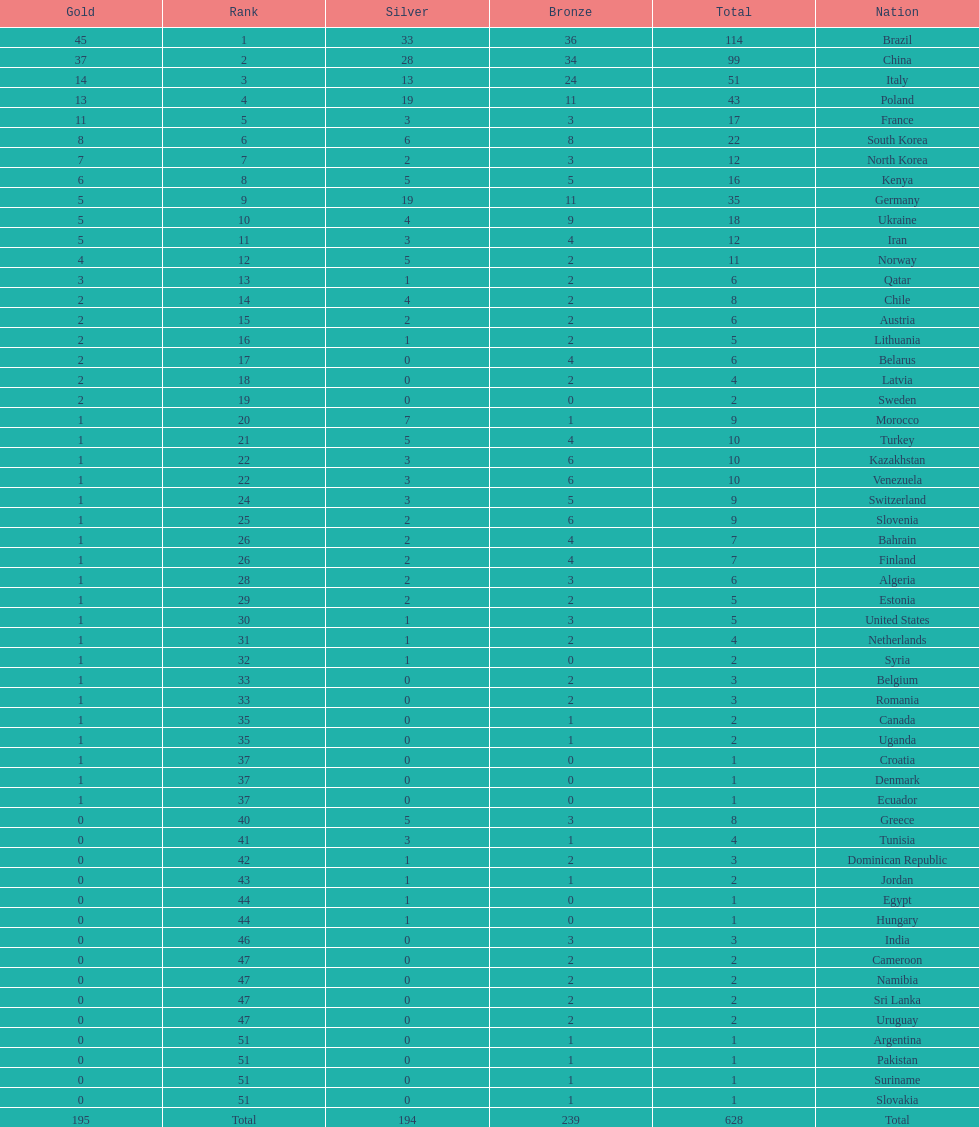Can you give me this table as a dict? {'header': ['Gold', 'Rank', 'Silver', 'Bronze', 'Total', 'Nation'], 'rows': [['45', '1', '33', '36', '114', 'Brazil'], ['37', '2', '28', '34', '99', 'China'], ['14', '3', '13', '24', '51', 'Italy'], ['13', '4', '19', '11', '43', 'Poland'], ['11', '5', '3', '3', '17', 'France'], ['8', '6', '6', '8', '22', 'South Korea'], ['7', '7', '2', '3', '12', 'North Korea'], ['6', '8', '5', '5', '16', 'Kenya'], ['5', '9', '19', '11', '35', 'Germany'], ['5', '10', '4', '9', '18', 'Ukraine'], ['5', '11', '3', '4', '12', 'Iran'], ['4', '12', '5', '2', '11', 'Norway'], ['3', '13', '1', '2', '6', 'Qatar'], ['2', '14', '4', '2', '8', 'Chile'], ['2', '15', '2', '2', '6', 'Austria'], ['2', '16', '1', '2', '5', 'Lithuania'], ['2', '17', '0', '4', '6', 'Belarus'], ['2', '18', '0', '2', '4', 'Latvia'], ['2', '19', '0', '0', '2', 'Sweden'], ['1', '20', '7', '1', '9', 'Morocco'], ['1', '21', '5', '4', '10', 'Turkey'], ['1', '22', '3', '6', '10', 'Kazakhstan'], ['1', '22', '3', '6', '10', 'Venezuela'], ['1', '24', '3', '5', '9', 'Switzerland'], ['1', '25', '2', '6', '9', 'Slovenia'], ['1', '26', '2', '4', '7', 'Bahrain'], ['1', '26', '2', '4', '7', 'Finland'], ['1', '28', '2', '3', '6', 'Algeria'], ['1', '29', '2', '2', '5', 'Estonia'], ['1', '30', '1', '3', '5', 'United States'], ['1', '31', '1', '2', '4', 'Netherlands'], ['1', '32', '1', '0', '2', 'Syria'], ['1', '33', '0', '2', '3', 'Belgium'], ['1', '33', '0', '2', '3', 'Romania'], ['1', '35', '0', '1', '2', 'Canada'], ['1', '35', '0', '1', '2', 'Uganda'], ['1', '37', '0', '0', '1', 'Croatia'], ['1', '37', '0', '0', '1', 'Denmark'], ['1', '37', '0', '0', '1', 'Ecuador'], ['0', '40', '5', '3', '8', 'Greece'], ['0', '41', '3', '1', '4', 'Tunisia'], ['0', '42', '1', '2', '3', 'Dominican Republic'], ['0', '43', '1', '1', '2', 'Jordan'], ['0', '44', '1', '0', '1', 'Egypt'], ['0', '44', '1', '0', '1', 'Hungary'], ['0', '46', '0', '3', '3', 'India'], ['0', '47', '0', '2', '2', 'Cameroon'], ['0', '47', '0', '2', '2', 'Namibia'], ['0', '47', '0', '2', '2', 'Sri Lanka'], ['0', '47', '0', '2', '2', 'Uruguay'], ['0', '51', '0', '1', '1', 'Argentina'], ['0', '51', '0', '1', '1', 'Pakistan'], ['0', '51', '0', '1', '1', 'Suriname'], ['0', '51', '0', '1', '1', 'Slovakia'], ['195', 'Total', '194', '239', '628', 'Total']]} Who won more gold medals, brazil or china? Brazil. 